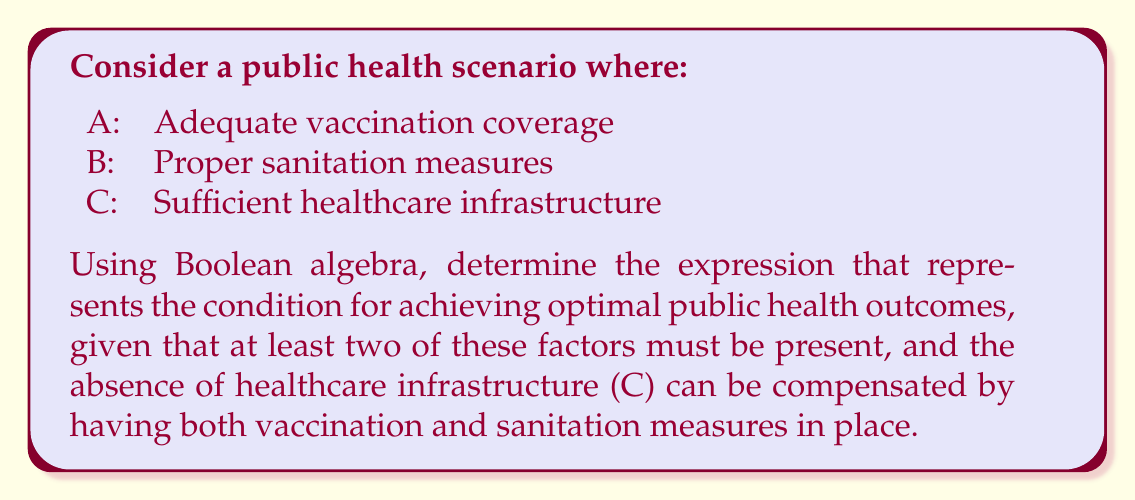Help me with this question. Let's approach this step-by-step using Boolean algebra:

1) First, we need to express "at least two factors must be present":
   $$(A \land B) \lor (A \land C) \lor (B \land C)$$

2) Next, we need to account for the compensation condition:
   If C is absent, both A and B must be present:
   $$(\lnot C \land A \land B)$$

3) Combining these conditions using OR (∨):
   $$((A \land B) \lor (A \land C) \lor (B \land C)) \lor (\lnot C \land A \land B)$$

4) Simplify using distributive property:
   $$(A \land B) \lor (A \land C) \lor (B \land C) \lor (\lnot C \land A \land B)$$

5) The term $(A \land B)$ appears twice, we can remove the redundancy:
   $$(A \land B) \lor (A \land C) \lor (B \land C)$$

This final expression represents the condition for optimal public health outcomes given the specified constraints.
Answer: $$(A \land B) \lor (A \land C) \lor (B \land C)$$ 